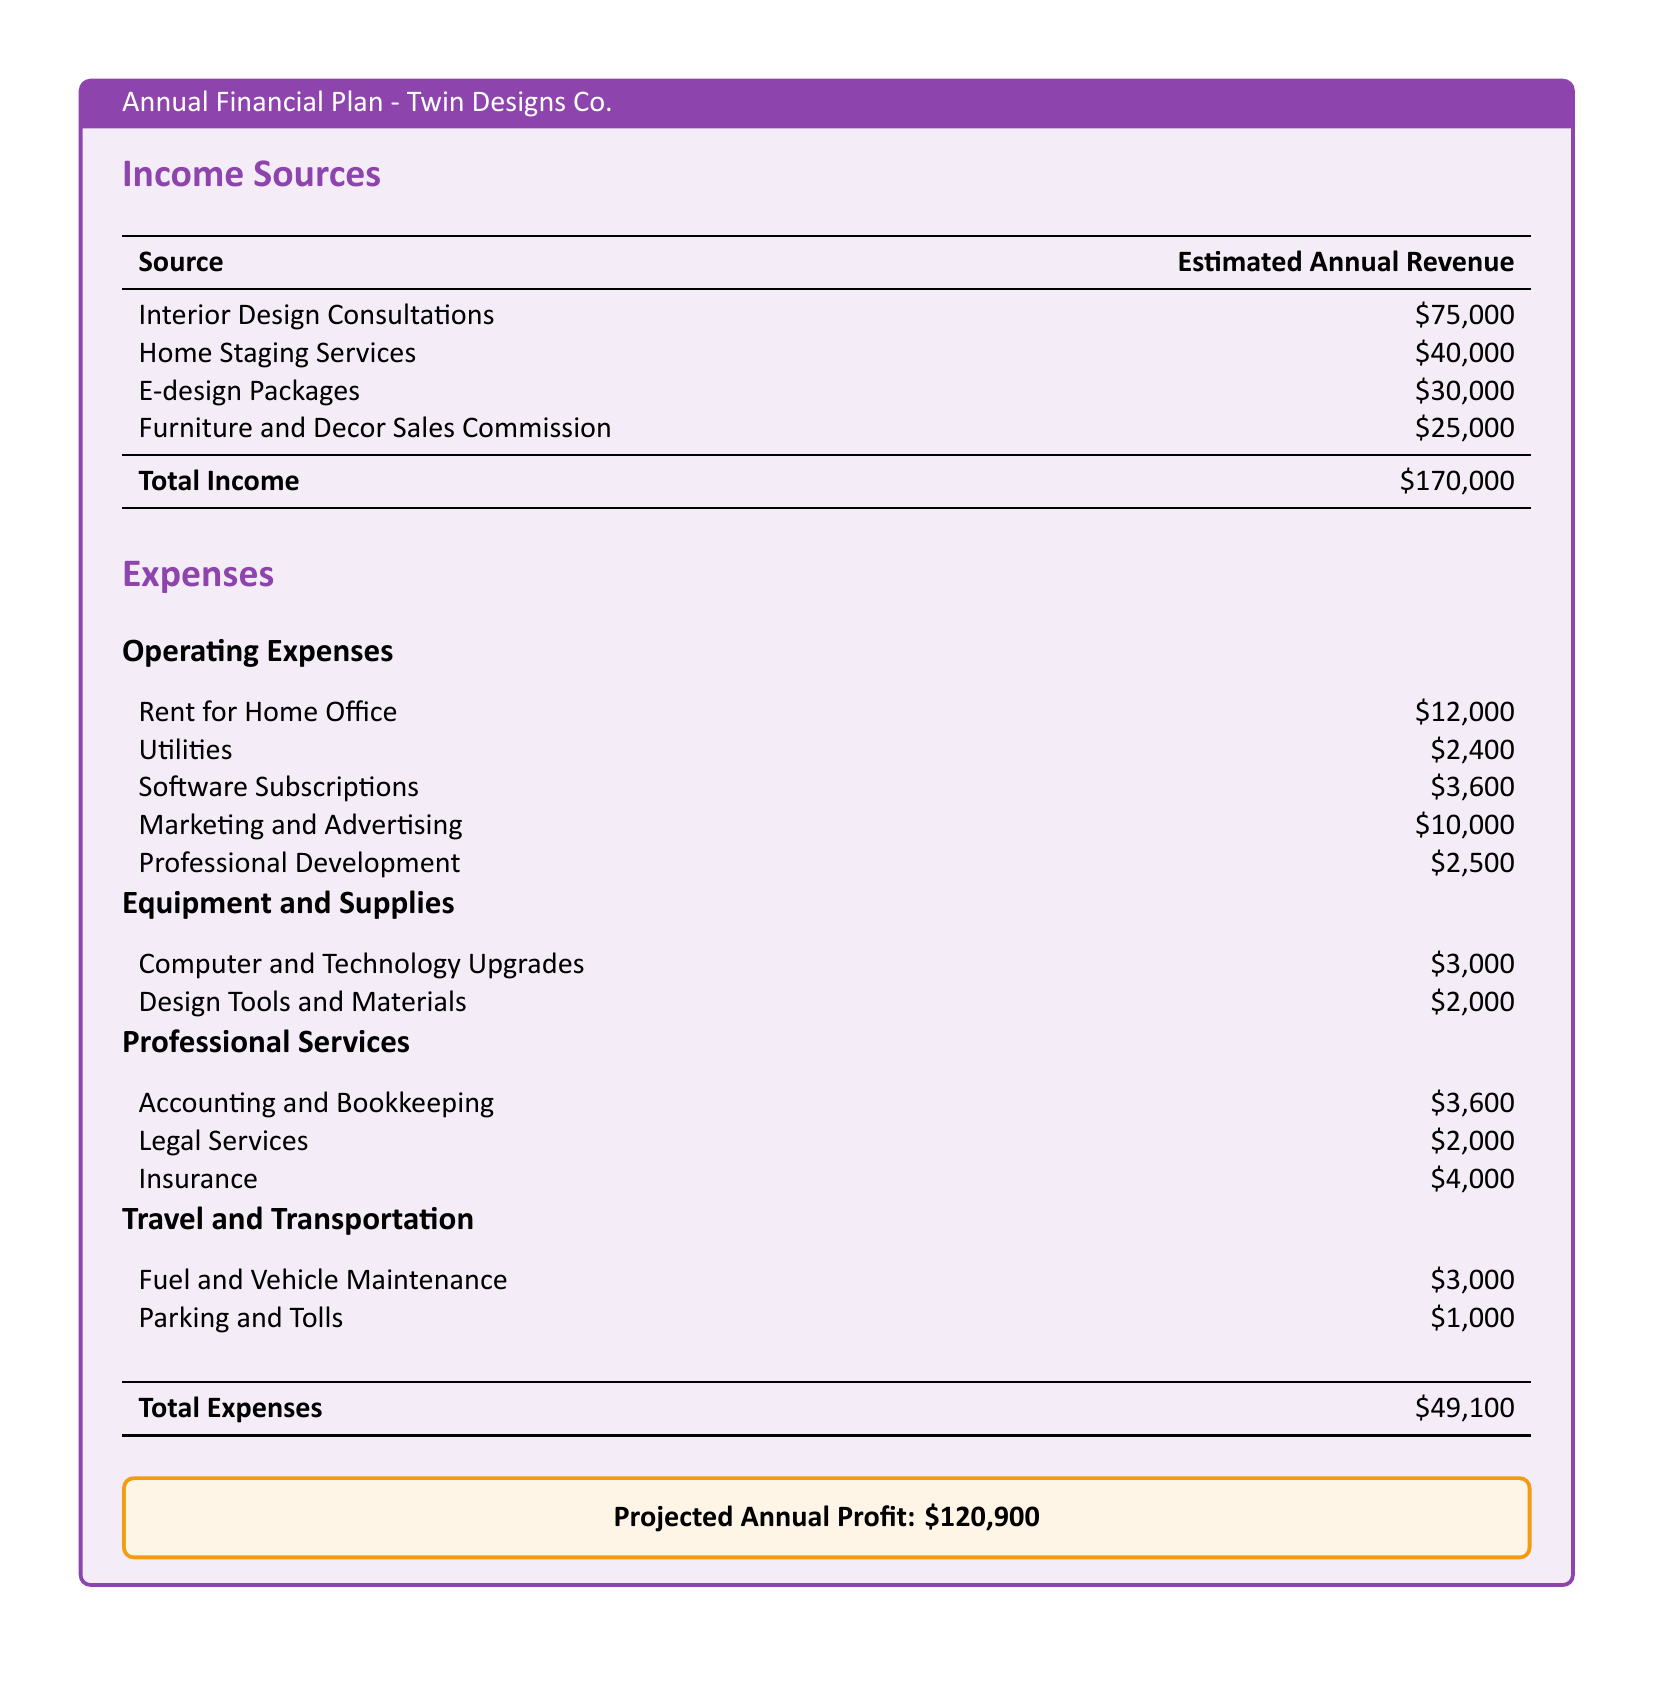what is the total income? The total income is the sum of all income sources: $75,000 + $40,000 + $30,000 + $25,000 = $170,000.
Answer: $170,000 what is the estimated revenue from Home Staging Services? The estimated revenue from Home Staging Services is specified in the income section of the document.
Answer: $40,000 what are the total operating expenses? The total operating expenses are the sum of all operating expenses listed, which equals $12,000 + $2,400 + $3,600 + $10,000 + $2,500 = $30,500.
Answer: $30,500 what is the amount allocated for legal services? The amount allocated for legal services is indicated in the professional services section of the document.
Answer: $2,000 how much is projected as annual profit? The projected annual profit is presented in the summary box at the end of the document.
Answer: $120,900 which expense category has the highest total? To determine this, one must examine the totals of each category, identifying the category with the largest sum among operating, equipment, and professional services.
Answer: Operating Expenses what is the total for travel and transportation expenses? The total for travel and transportation expenses is the sum of fuel and vehicle maintenance and parking and tolls.
Answer: $4,000 what is the total amount spent on marketing and advertising? The amount spent on marketing and advertising is listed among the operating expenses.
Answer: $10,000 what is the estimated annual revenue from E-design Packages? The estimated annual revenue from E-design Packages is specified in the income section.
Answer: $30,000 